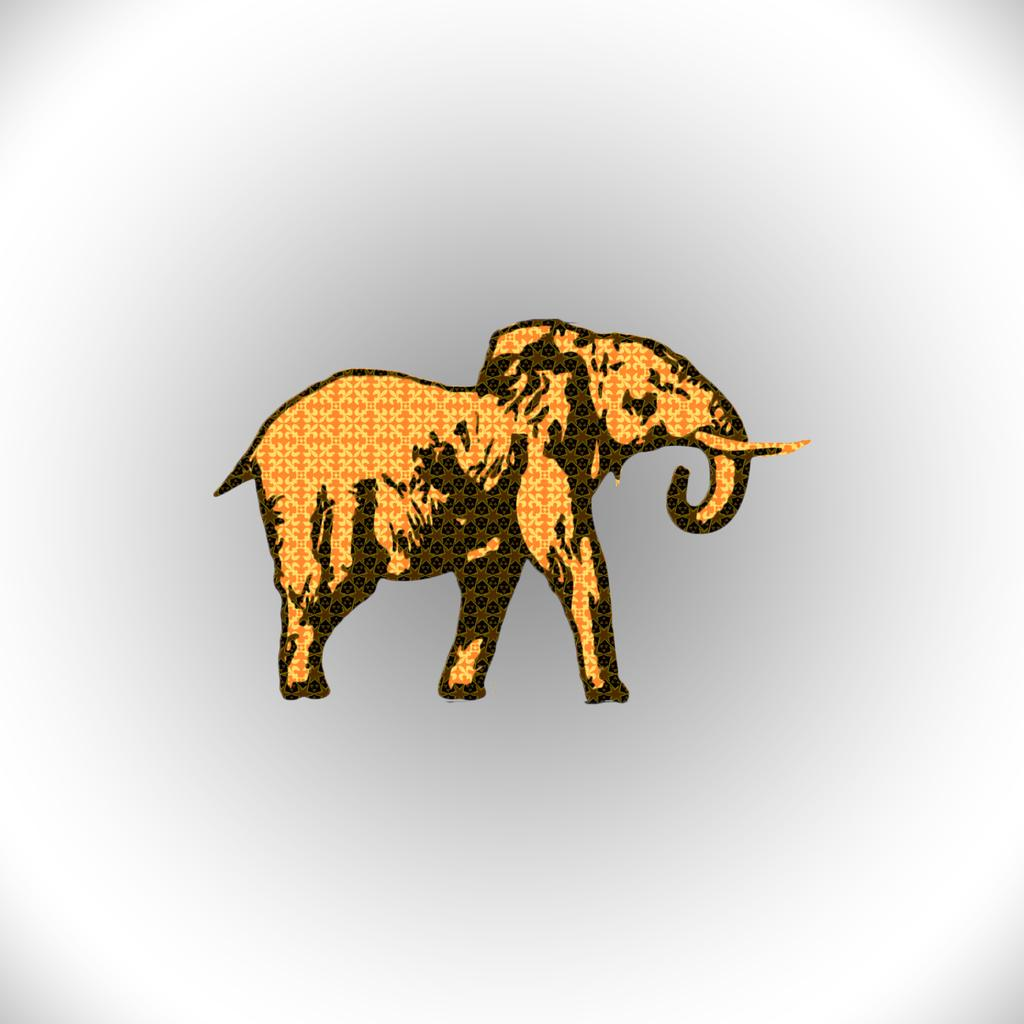What is the main subject of the painting in the image? There is a painting of an elephant in the image. What color is the background of the painting? The background of the image is white. What type of icicle can be seen hanging from the elephant's trunk in the image? There is no icicle present in the image; it is a painting of an elephant with a white background. 